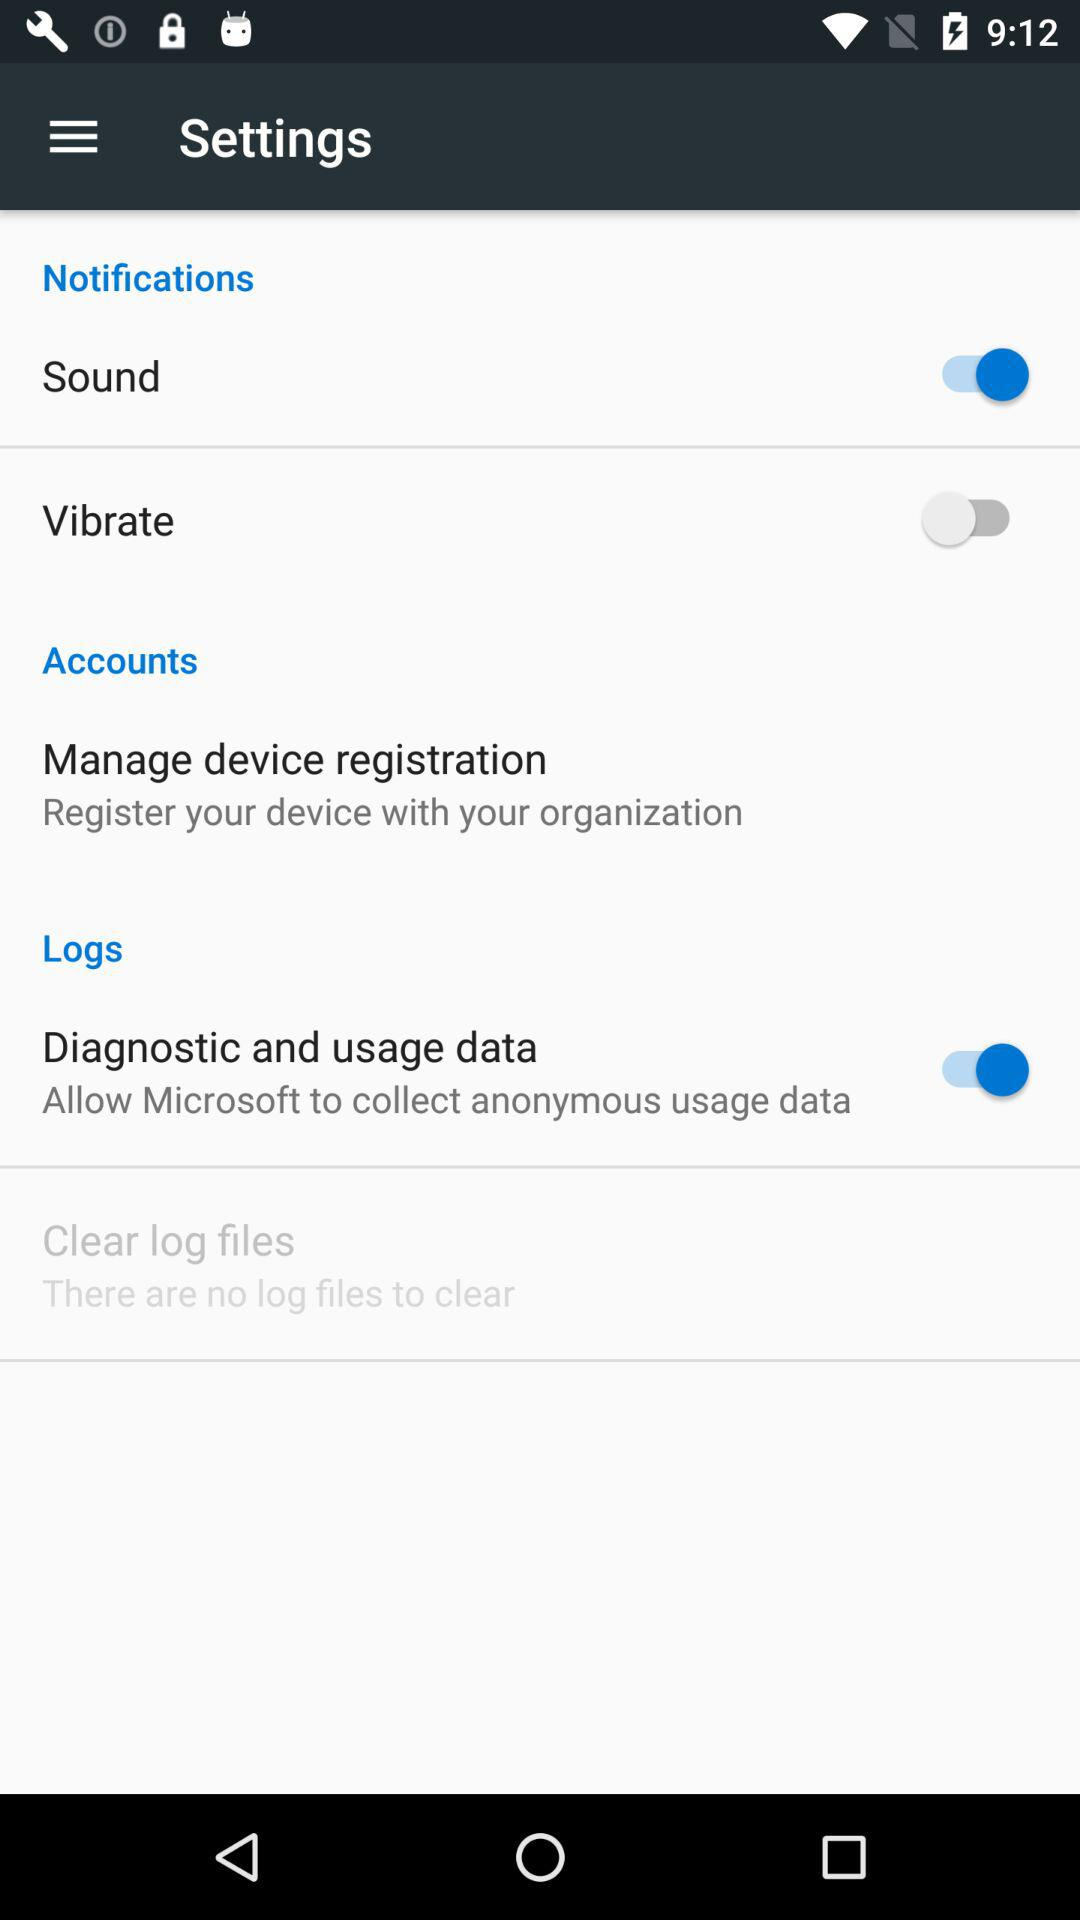How many items in the 'Notifications' section have a switch?
Answer the question using a single word or phrase. 2 